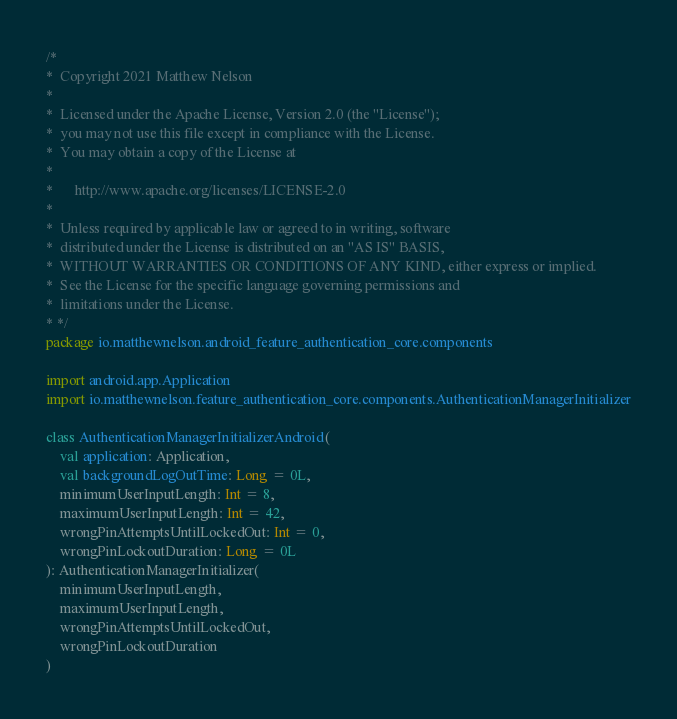<code> <loc_0><loc_0><loc_500><loc_500><_Kotlin_>/*
*  Copyright 2021 Matthew Nelson
*
*  Licensed under the Apache License, Version 2.0 (the "License");
*  you may not use this file except in compliance with the License.
*  You may obtain a copy of the License at
*
*      http://www.apache.org/licenses/LICENSE-2.0
*
*  Unless required by applicable law or agreed to in writing, software
*  distributed under the License is distributed on an "AS IS" BASIS,
*  WITHOUT WARRANTIES OR CONDITIONS OF ANY KIND, either express or implied.
*  See the License for the specific language governing permissions and
*  limitations under the License.
* */
package io.matthewnelson.android_feature_authentication_core.components

import android.app.Application
import io.matthewnelson.feature_authentication_core.components.AuthenticationManagerInitializer

class AuthenticationManagerInitializerAndroid(
    val application: Application,
    val backgroundLogOutTime: Long = 0L,
    minimumUserInputLength: Int = 8,
    maximumUserInputLength: Int = 42,
    wrongPinAttemptsUntilLockedOut: Int = 0,
    wrongPinLockoutDuration: Long = 0L
): AuthenticationManagerInitializer(
    minimumUserInputLength,
    maximumUserInputLength,
    wrongPinAttemptsUntilLockedOut,
    wrongPinLockoutDuration
)
</code> 